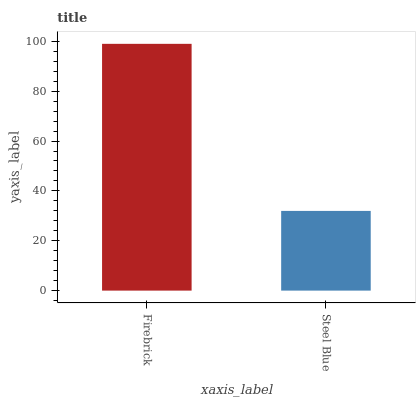Is Steel Blue the maximum?
Answer yes or no. No. Is Firebrick greater than Steel Blue?
Answer yes or no. Yes. Is Steel Blue less than Firebrick?
Answer yes or no. Yes. Is Steel Blue greater than Firebrick?
Answer yes or no. No. Is Firebrick less than Steel Blue?
Answer yes or no. No. Is Firebrick the high median?
Answer yes or no. Yes. Is Steel Blue the low median?
Answer yes or no. Yes. Is Steel Blue the high median?
Answer yes or no. No. Is Firebrick the low median?
Answer yes or no. No. 